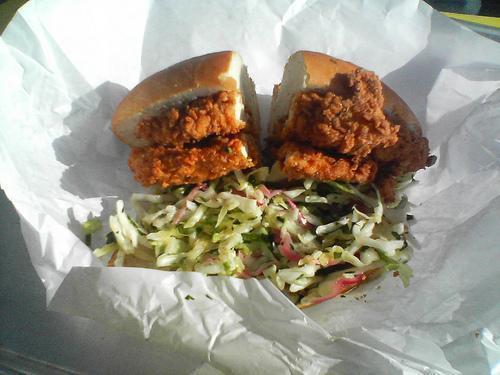How many pieces is the sandwich cut into?
Give a very brief answer. 2. How many sandwiches are there?
Give a very brief answer. 2. 